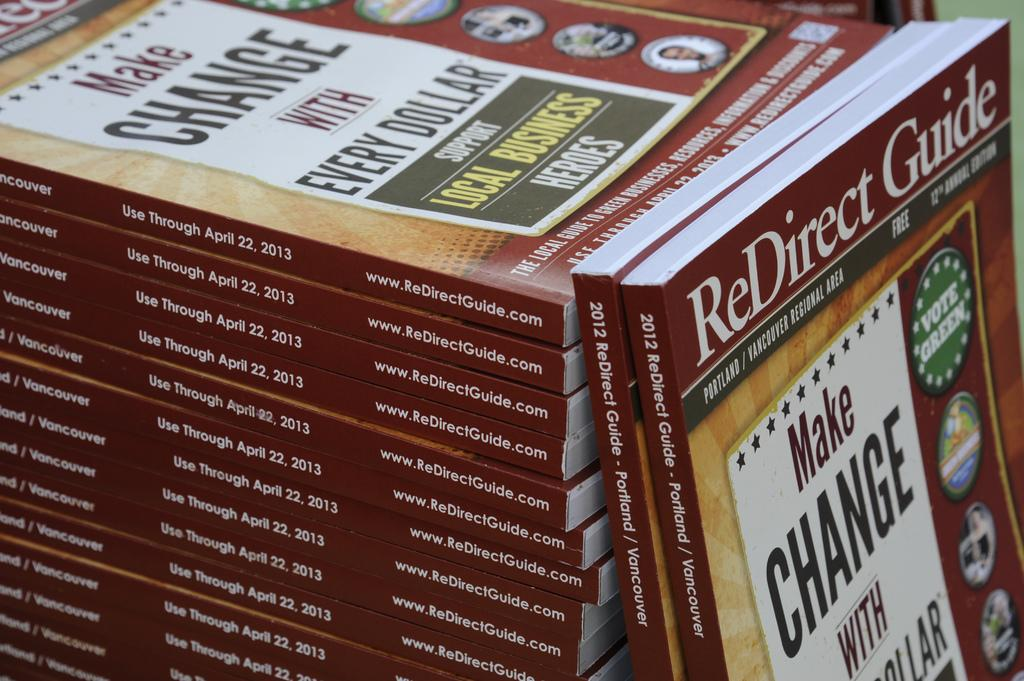<image>
Summarize the visual content of the image. stack of make change with every dollar books 